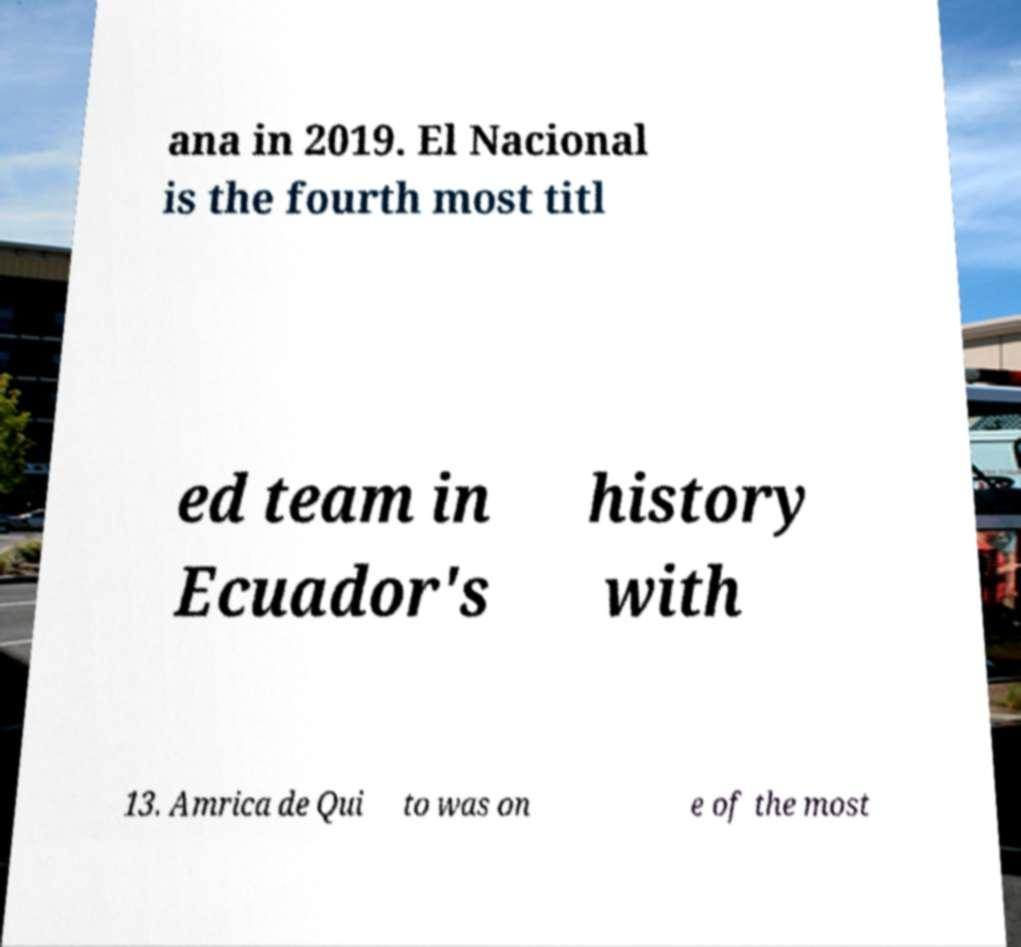Could you extract and type out the text from this image? ana in 2019. El Nacional is the fourth most titl ed team in Ecuador's history with 13. Amrica de Qui to was on e of the most 